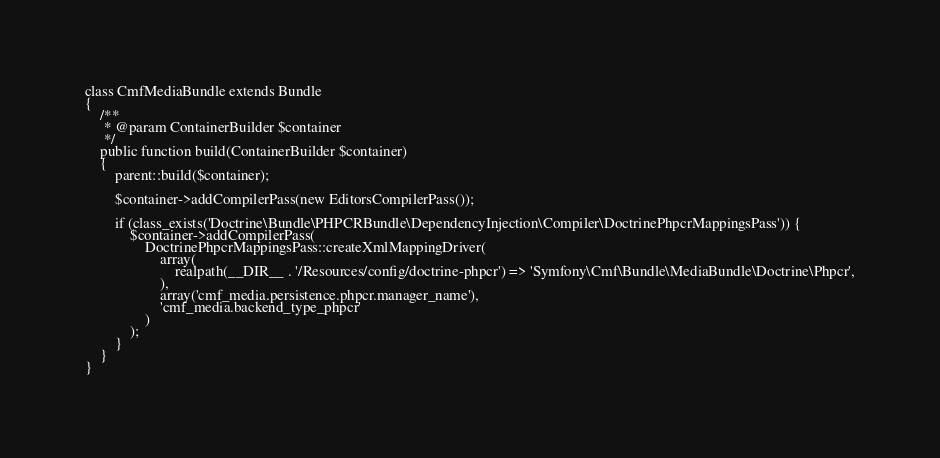<code> <loc_0><loc_0><loc_500><loc_500><_PHP_>
class CmfMediaBundle extends Bundle
{
    /**
     * @param ContainerBuilder $container
     */
    public function build(ContainerBuilder $container)
    {
        parent::build($container);

        $container->addCompilerPass(new EditorsCompilerPass());

        if (class_exists('Doctrine\Bundle\PHPCRBundle\DependencyInjection\Compiler\DoctrinePhpcrMappingsPass')) {
            $container->addCompilerPass(
                DoctrinePhpcrMappingsPass::createXmlMappingDriver(
                    array(
                        realpath(__DIR__ . '/Resources/config/doctrine-phpcr') => 'Symfony\Cmf\Bundle\MediaBundle\Doctrine\Phpcr',
                    ),
                    array('cmf_media.persistence.phpcr.manager_name'),
                    'cmf_media.backend_type_phpcr'
                )
            );
        }
    }
}
</code> 